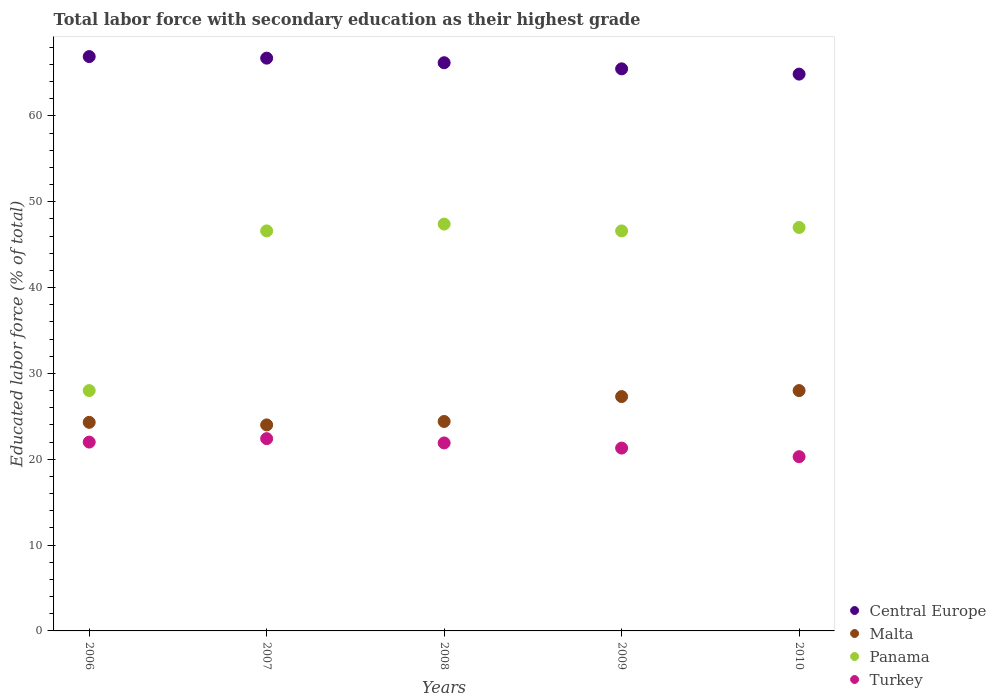How many different coloured dotlines are there?
Provide a succinct answer. 4. What is the percentage of total labor force with primary education in Central Europe in 2009?
Offer a very short reply. 65.48. Across all years, what is the maximum percentage of total labor force with primary education in Turkey?
Your response must be concise. 22.4. Across all years, what is the minimum percentage of total labor force with primary education in Turkey?
Your response must be concise. 20.3. What is the total percentage of total labor force with primary education in Malta in the graph?
Your answer should be compact. 128. What is the difference between the percentage of total labor force with primary education in Turkey in 2006 and that in 2008?
Offer a terse response. 0.1. What is the difference between the percentage of total labor force with primary education in Panama in 2008 and the percentage of total labor force with primary education in Central Europe in 2010?
Make the answer very short. -17.47. What is the average percentage of total labor force with primary education in Panama per year?
Ensure brevity in your answer.  43.12. In the year 2006, what is the difference between the percentage of total labor force with primary education in Malta and percentage of total labor force with primary education in Panama?
Keep it short and to the point. -3.7. In how many years, is the percentage of total labor force with primary education in Central Europe greater than 2 %?
Ensure brevity in your answer.  5. What is the difference between the highest and the second highest percentage of total labor force with primary education in Central Europe?
Provide a succinct answer. 0.18. What is the difference between the highest and the lowest percentage of total labor force with primary education in Turkey?
Provide a short and direct response. 2.1. In how many years, is the percentage of total labor force with primary education in Malta greater than the average percentage of total labor force with primary education in Malta taken over all years?
Your response must be concise. 2. Is the sum of the percentage of total labor force with primary education in Turkey in 2007 and 2009 greater than the maximum percentage of total labor force with primary education in Malta across all years?
Provide a succinct answer. Yes. Does the percentage of total labor force with primary education in Panama monotonically increase over the years?
Ensure brevity in your answer.  No. How many years are there in the graph?
Keep it short and to the point. 5. What is the difference between two consecutive major ticks on the Y-axis?
Offer a terse response. 10. Does the graph contain grids?
Give a very brief answer. No. Where does the legend appear in the graph?
Provide a short and direct response. Bottom right. How many legend labels are there?
Your answer should be compact. 4. How are the legend labels stacked?
Keep it short and to the point. Vertical. What is the title of the graph?
Offer a terse response. Total labor force with secondary education as their highest grade. Does "Nepal" appear as one of the legend labels in the graph?
Offer a terse response. No. What is the label or title of the Y-axis?
Keep it short and to the point. Educated labor force (% of total). What is the Educated labor force (% of total) in Central Europe in 2006?
Ensure brevity in your answer.  66.91. What is the Educated labor force (% of total) in Malta in 2006?
Keep it short and to the point. 24.3. What is the Educated labor force (% of total) in Turkey in 2006?
Keep it short and to the point. 22. What is the Educated labor force (% of total) in Central Europe in 2007?
Ensure brevity in your answer.  66.73. What is the Educated labor force (% of total) of Panama in 2007?
Your response must be concise. 46.6. What is the Educated labor force (% of total) in Turkey in 2007?
Keep it short and to the point. 22.4. What is the Educated labor force (% of total) of Central Europe in 2008?
Your answer should be compact. 66.19. What is the Educated labor force (% of total) of Malta in 2008?
Keep it short and to the point. 24.4. What is the Educated labor force (% of total) of Panama in 2008?
Offer a very short reply. 47.4. What is the Educated labor force (% of total) of Turkey in 2008?
Provide a succinct answer. 21.9. What is the Educated labor force (% of total) in Central Europe in 2009?
Offer a very short reply. 65.48. What is the Educated labor force (% of total) of Malta in 2009?
Your answer should be compact. 27.3. What is the Educated labor force (% of total) in Panama in 2009?
Provide a succinct answer. 46.6. What is the Educated labor force (% of total) of Turkey in 2009?
Provide a succinct answer. 21.3. What is the Educated labor force (% of total) of Central Europe in 2010?
Provide a succinct answer. 64.87. What is the Educated labor force (% of total) in Turkey in 2010?
Your answer should be compact. 20.3. Across all years, what is the maximum Educated labor force (% of total) of Central Europe?
Provide a short and direct response. 66.91. Across all years, what is the maximum Educated labor force (% of total) of Panama?
Offer a very short reply. 47.4. Across all years, what is the maximum Educated labor force (% of total) in Turkey?
Provide a succinct answer. 22.4. Across all years, what is the minimum Educated labor force (% of total) in Central Europe?
Make the answer very short. 64.87. Across all years, what is the minimum Educated labor force (% of total) of Malta?
Keep it short and to the point. 24. Across all years, what is the minimum Educated labor force (% of total) of Panama?
Provide a short and direct response. 28. Across all years, what is the minimum Educated labor force (% of total) in Turkey?
Your answer should be very brief. 20.3. What is the total Educated labor force (% of total) in Central Europe in the graph?
Give a very brief answer. 330.18. What is the total Educated labor force (% of total) of Malta in the graph?
Your response must be concise. 128. What is the total Educated labor force (% of total) of Panama in the graph?
Make the answer very short. 215.6. What is the total Educated labor force (% of total) of Turkey in the graph?
Give a very brief answer. 107.9. What is the difference between the Educated labor force (% of total) of Central Europe in 2006 and that in 2007?
Make the answer very short. 0.18. What is the difference between the Educated labor force (% of total) in Panama in 2006 and that in 2007?
Ensure brevity in your answer.  -18.6. What is the difference between the Educated labor force (% of total) in Central Europe in 2006 and that in 2008?
Offer a very short reply. 0.72. What is the difference between the Educated labor force (% of total) of Panama in 2006 and that in 2008?
Ensure brevity in your answer.  -19.4. What is the difference between the Educated labor force (% of total) of Central Europe in 2006 and that in 2009?
Your answer should be compact. 1.43. What is the difference between the Educated labor force (% of total) in Malta in 2006 and that in 2009?
Your response must be concise. -3. What is the difference between the Educated labor force (% of total) in Panama in 2006 and that in 2009?
Provide a short and direct response. -18.6. What is the difference between the Educated labor force (% of total) of Central Europe in 2006 and that in 2010?
Make the answer very short. 2.04. What is the difference between the Educated labor force (% of total) of Central Europe in 2007 and that in 2008?
Offer a terse response. 0.53. What is the difference between the Educated labor force (% of total) of Panama in 2007 and that in 2008?
Ensure brevity in your answer.  -0.8. What is the difference between the Educated labor force (% of total) in Central Europe in 2007 and that in 2009?
Give a very brief answer. 1.25. What is the difference between the Educated labor force (% of total) of Malta in 2007 and that in 2009?
Keep it short and to the point. -3.3. What is the difference between the Educated labor force (% of total) of Central Europe in 2007 and that in 2010?
Keep it short and to the point. 1.86. What is the difference between the Educated labor force (% of total) of Malta in 2007 and that in 2010?
Make the answer very short. -4. What is the difference between the Educated labor force (% of total) of Panama in 2007 and that in 2010?
Your response must be concise. -0.4. What is the difference between the Educated labor force (% of total) of Turkey in 2007 and that in 2010?
Ensure brevity in your answer.  2.1. What is the difference between the Educated labor force (% of total) of Central Europe in 2008 and that in 2009?
Offer a very short reply. 0.71. What is the difference between the Educated labor force (% of total) in Malta in 2008 and that in 2009?
Your response must be concise. -2.9. What is the difference between the Educated labor force (% of total) of Panama in 2008 and that in 2009?
Your answer should be compact. 0.8. What is the difference between the Educated labor force (% of total) in Central Europe in 2008 and that in 2010?
Your response must be concise. 1.33. What is the difference between the Educated labor force (% of total) of Malta in 2008 and that in 2010?
Make the answer very short. -3.6. What is the difference between the Educated labor force (% of total) of Panama in 2008 and that in 2010?
Give a very brief answer. 0.4. What is the difference between the Educated labor force (% of total) in Central Europe in 2009 and that in 2010?
Ensure brevity in your answer.  0.61. What is the difference between the Educated labor force (% of total) in Malta in 2009 and that in 2010?
Offer a terse response. -0.7. What is the difference between the Educated labor force (% of total) of Central Europe in 2006 and the Educated labor force (% of total) of Malta in 2007?
Offer a very short reply. 42.91. What is the difference between the Educated labor force (% of total) of Central Europe in 2006 and the Educated labor force (% of total) of Panama in 2007?
Your response must be concise. 20.31. What is the difference between the Educated labor force (% of total) in Central Europe in 2006 and the Educated labor force (% of total) in Turkey in 2007?
Provide a short and direct response. 44.51. What is the difference between the Educated labor force (% of total) of Malta in 2006 and the Educated labor force (% of total) of Panama in 2007?
Your answer should be compact. -22.3. What is the difference between the Educated labor force (% of total) in Malta in 2006 and the Educated labor force (% of total) in Turkey in 2007?
Your response must be concise. 1.9. What is the difference between the Educated labor force (% of total) in Central Europe in 2006 and the Educated labor force (% of total) in Malta in 2008?
Provide a short and direct response. 42.51. What is the difference between the Educated labor force (% of total) of Central Europe in 2006 and the Educated labor force (% of total) of Panama in 2008?
Offer a terse response. 19.51. What is the difference between the Educated labor force (% of total) of Central Europe in 2006 and the Educated labor force (% of total) of Turkey in 2008?
Provide a short and direct response. 45.01. What is the difference between the Educated labor force (% of total) in Malta in 2006 and the Educated labor force (% of total) in Panama in 2008?
Provide a succinct answer. -23.1. What is the difference between the Educated labor force (% of total) of Malta in 2006 and the Educated labor force (% of total) of Turkey in 2008?
Ensure brevity in your answer.  2.4. What is the difference between the Educated labor force (% of total) of Central Europe in 2006 and the Educated labor force (% of total) of Malta in 2009?
Offer a very short reply. 39.61. What is the difference between the Educated labor force (% of total) of Central Europe in 2006 and the Educated labor force (% of total) of Panama in 2009?
Give a very brief answer. 20.31. What is the difference between the Educated labor force (% of total) in Central Europe in 2006 and the Educated labor force (% of total) in Turkey in 2009?
Your response must be concise. 45.61. What is the difference between the Educated labor force (% of total) in Malta in 2006 and the Educated labor force (% of total) in Panama in 2009?
Keep it short and to the point. -22.3. What is the difference between the Educated labor force (% of total) in Panama in 2006 and the Educated labor force (% of total) in Turkey in 2009?
Give a very brief answer. 6.7. What is the difference between the Educated labor force (% of total) of Central Europe in 2006 and the Educated labor force (% of total) of Malta in 2010?
Ensure brevity in your answer.  38.91. What is the difference between the Educated labor force (% of total) in Central Europe in 2006 and the Educated labor force (% of total) in Panama in 2010?
Provide a succinct answer. 19.91. What is the difference between the Educated labor force (% of total) in Central Europe in 2006 and the Educated labor force (% of total) in Turkey in 2010?
Your answer should be very brief. 46.61. What is the difference between the Educated labor force (% of total) of Malta in 2006 and the Educated labor force (% of total) of Panama in 2010?
Provide a short and direct response. -22.7. What is the difference between the Educated labor force (% of total) of Panama in 2006 and the Educated labor force (% of total) of Turkey in 2010?
Offer a very short reply. 7.7. What is the difference between the Educated labor force (% of total) in Central Europe in 2007 and the Educated labor force (% of total) in Malta in 2008?
Keep it short and to the point. 42.33. What is the difference between the Educated labor force (% of total) in Central Europe in 2007 and the Educated labor force (% of total) in Panama in 2008?
Make the answer very short. 19.33. What is the difference between the Educated labor force (% of total) in Central Europe in 2007 and the Educated labor force (% of total) in Turkey in 2008?
Offer a very short reply. 44.83. What is the difference between the Educated labor force (% of total) of Malta in 2007 and the Educated labor force (% of total) of Panama in 2008?
Make the answer very short. -23.4. What is the difference between the Educated labor force (% of total) in Malta in 2007 and the Educated labor force (% of total) in Turkey in 2008?
Offer a terse response. 2.1. What is the difference between the Educated labor force (% of total) of Panama in 2007 and the Educated labor force (% of total) of Turkey in 2008?
Keep it short and to the point. 24.7. What is the difference between the Educated labor force (% of total) of Central Europe in 2007 and the Educated labor force (% of total) of Malta in 2009?
Offer a terse response. 39.43. What is the difference between the Educated labor force (% of total) of Central Europe in 2007 and the Educated labor force (% of total) of Panama in 2009?
Your answer should be compact. 20.13. What is the difference between the Educated labor force (% of total) in Central Europe in 2007 and the Educated labor force (% of total) in Turkey in 2009?
Your answer should be compact. 45.43. What is the difference between the Educated labor force (% of total) of Malta in 2007 and the Educated labor force (% of total) of Panama in 2009?
Offer a very short reply. -22.6. What is the difference between the Educated labor force (% of total) of Malta in 2007 and the Educated labor force (% of total) of Turkey in 2009?
Keep it short and to the point. 2.7. What is the difference between the Educated labor force (% of total) in Panama in 2007 and the Educated labor force (% of total) in Turkey in 2009?
Provide a succinct answer. 25.3. What is the difference between the Educated labor force (% of total) of Central Europe in 2007 and the Educated labor force (% of total) of Malta in 2010?
Offer a terse response. 38.73. What is the difference between the Educated labor force (% of total) of Central Europe in 2007 and the Educated labor force (% of total) of Panama in 2010?
Keep it short and to the point. 19.73. What is the difference between the Educated labor force (% of total) of Central Europe in 2007 and the Educated labor force (% of total) of Turkey in 2010?
Your answer should be very brief. 46.43. What is the difference between the Educated labor force (% of total) in Panama in 2007 and the Educated labor force (% of total) in Turkey in 2010?
Offer a terse response. 26.3. What is the difference between the Educated labor force (% of total) of Central Europe in 2008 and the Educated labor force (% of total) of Malta in 2009?
Give a very brief answer. 38.89. What is the difference between the Educated labor force (% of total) in Central Europe in 2008 and the Educated labor force (% of total) in Panama in 2009?
Give a very brief answer. 19.59. What is the difference between the Educated labor force (% of total) in Central Europe in 2008 and the Educated labor force (% of total) in Turkey in 2009?
Offer a very short reply. 44.89. What is the difference between the Educated labor force (% of total) of Malta in 2008 and the Educated labor force (% of total) of Panama in 2009?
Offer a terse response. -22.2. What is the difference between the Educated labor force (% of total) in Panama in 2008 and the Educated labor force (% of total) in Turkey in 2009?
Make the answer very short. 26.1. What is the difference between the Educated labor force (% of total) of Central Europe in 2008 and the Educated labor force (% of total) of Malta in 2010?
Your response must be concise. 38.19. What is the difference between the Educated labor force (% of total) in Central Europe in 2008 and the Educated labor force (% of total) in Panama in 2010?
Give a very brief answer. 19.19. What is the difference between the Educated labor force (% of total) in Central Europe in 2008 and the Educated labor force (% of total) in Turkey in 2010?
Offer a terse response. 45.89. What is the difference between the Educated labor force (% of total) of Malta in 2008 and the Educated labor force (% of total) of Panama in 2010?
Your response must be concise. -22.6. What is the difference between the Educated labor force (% of total) of Malta in 2008 and the Educated labor force (% of total) of Turkey in 2010?
Give a very brief answer. 4.1. What is the difference between the Educated labor force (% of total) of Panama in 2008 and the Educated labor force (% of total) of Turkey in 2010?
Your answer should be very brief. 27.1. What is the difference between the Educated labor force (% of total) of Central Europe in 2009 and the Educated labor force (% of total) of Malta in 2010?
Offer a very short reply. 37.48. What is the difference between the Educated labor force (% of total) in Central Europe in 2009 and the Educated labor force (% of total) in Panama in 2010?
Your answer should be very brief. 18.48. What is the difference between the Educated labor force (% of total) of Central Europe in 2009 and the Educated labor force (% of total) of Turkey in 2010?
Provide a short and direct response. 45.18. What is the difference between the Educated labor force (% of total) in Malta in 2009 and the Educated labor force (% of total) in Panama in 2010?
Offer a terse response. -19.7. What is the difference between the Educated labor force (% of total) of Malta in 2009 and the Educated labor force (% of total) of Turkey in 2010?
Your answer should be very brief. 7. What is the difference between the Educated labor force (% of total) in Panama in 2009 and the Educated labor force (% of total) in Turkey in 2010?
Offer a terse response. 26.3. What is the average Educated labor force (% of total) of Central Europe per year?
Your answer should be compact. 66.04. What is the average Educated labor force (% of total) of Malta per year?
Give a very brief answer. 25.6. What is the average Educated labor force (% of total) of Panama per year?
Keep it short and to the point. 43.12. What is the average Educated labor force (% of total) of Turkey per year?
Your response must be concise. 21.58. In the year 2006, what is the difference between the Educated labor force (% of total) in Central Europe and Educated labor force (% of total) in Malta?
Your answer should be very brief. 42.61. In the year 2006, what is the difference between the Educated labor force (% of total) in Central Europe and Educated labor force (% of total) in Panama?
Offer a very short reply. 38.91. In the year 2006, what is the difference between the Educated labor force (% of total) in Central Europe and Educated labor force (% of total) in Turkey?
Ensure brevity in your answer.  44.91. In the year 2006, what is the difference between the Educated labor force (% of total) of Malta and Educated labor force (% of total) of Turkey?
Offer a very short reply. 2.3. In the year 2007, what is the difference between the Educated labor force (% of total) in Central Europe and Educated labor force (% of total) in Malta?
Offer a very short reply. 42.73. In the year 2007, what is the difference between the Educated labor force (% of total) of Central Europe and Educated labor force (% of total) of Panama?
Provide a succinct answer. 20.13. In the year 2007, what is the difference between the Educated labor force (% of total) in Central Europe and Educated labor force (% of total) in Turkey?
Offer a very short reply. 44.33. In the year 2007, what is the difference between the Educated labor force (% of total) in Malta and Educated labor force (% of total) in Panama?
Your answer should be very brief. -22.6. In the year 2007, what is the difference between the Educated labor force (% of total) in Malta and Educated labor force (% of total) in Turkey?
Your answer should be compact. 1.6. In the year 2007, what is the difference between the Educated labor force (% of total) in Panama and Educated labor force (% of total) in Turkey?
Offer a very short reply. 24.2. In the year 2008, what is the difference between the Educated labor force (% of total) of Central Europe and Educated labor force (% of total) of Malta?
Provide a short and direct response. 41.79. In the year 2008, what is the difference between the Educated labor force (% of total) in Central Europe and Educated labor force (% of total) in Panama?
Make the answer very short. 18.79. In the year 2008, what is the difference between the Educated labor force (% of total) in Central Europe and Educated labor force (% of total) in Turkey?
Offer a very short reply. 44.29. In the year 2008, what is the difference between the Educated labor force (% of total) in Malta and Educated labor force (% of total) in Panama?
Your response must be concise. -23. In the year 2008, what is the difference between the Educated labor force (% of total) in Malta and Educated labor force (% of total) in Turkey?
Give a very brief answer. 2.5. In the year 2009, what is the difference between the Educated labor force (% of total) of Central Europe and Educated labor force (% of total) of Malta?
Provide a succinct answer. 38.18. In the year 2009, what is the difference between the Educated labor force (% of total) of Central Europe and Educated labor force (% of total) of Panama?
Keep it short and to the point. 18.88. In the year 2009, what is the difference between the Educated labor force (% of total) of Central Europe and Educated labor force (% of total) of Turkey?
Offer a terse response. 44.18. In the year 2009, what is the difference between the Educated labor force (% of total) in Malta and Educated labor force (% of total) in Panama?
Give a very brief answer. -19.3. In the year 2009, what is the difference between the Educated labor force (% of total) in Malta and Educated labor force (% of total) in Turkey?
Offer a terse response. 6. In the year 2009, what is the difference between the Educated labor force (% of total) in Panama and Educated labor force (% of total) in Turkey?
Give a very brief answer. 25.3. In the year 2010, what is the difference between the Educated labor force (% of total) of Central Europe and Educated labor force (% of total) of Malta?
Offer a very short reply. 36.87. In the year 2010, what is the difference between the Educated labor force (% of total) of Central Europe and Educated labor force (% of total) of Panama?
Offer a very short reply. 17.87. In the year 2010, what is the difference between the Educated labor force (% of total) in Central Europe and Educated labor force (% of total) in Turkey?
Keep it short and to the point. 44.57. In the year 2010, what is the difference between the Educated labor force (% of total) in Malta and Educated labor force (% of total) in Turkey?
Your answer should be very brief. 7.7. In the year 2010, what is the difference between the Educated labor force (% of total) in Panama and Educated labor force (% of total) in Turkey?
Your answer should be compact. 26.7. What is the ratio of the Educated labor force (% of total) of Malta in 2006 to that in 2007?
Your answer should be very brief. 1.01. What is the ratio of the Educated labor force (% of total) in Panama in 2006 to that in 2007?
Your answer should be very brief. 0.6. What is the ratio of the Educated labor force (% of total) of Turkey in 2006 to that in 2007?
Give a very brief answer. 0.98. What is the ratio of the Educated labor force (% of total) of Central Europe in 2006 to that in 2008?
Offer a terse response. 1.01. What is the ratio of the Educated labor force (% of total) of Panama in 2006 to that in 2008?
Your answer should be compact. 0.59. What is the ratio of the Educated labor force (% of total) in Turkey in 2006 to that in 2008?
Give a very brief answer. 1. What is the ratio of the Educated labor force (% of total) in Central Europe in 2006 to that in 2009?
Keep it short and to the point. 1.02. What is the ratio of the Educated labor force (% of total) in Malta in 2006 to that in 2009?
Give a very brief answer. 0.89. What is the ratio of the Educated labor force (% of total) in Panama in 2006 to that in 2009?
Keep it short and to the point. 0.6. What is the ratio of the Educated labor force (% of total) in Turkey in 2006 to that in 2009?
Your response must be concise. 1.03. What is the ratio of the Educated labor force (% of total) of Central Europe in 2006 to that in 2010?
Your answer should be compact. 1.03. What is the ratio of the Educated labor force (% of total) of Malta in 2006 to that in 2010?
Your response must be concise. 0.87. What is the ratio of the Educated labor force (% of total) of Panama in 2006 to that in 2010?
Your answer should be compact. 0.6. What is the ratio of the Educated labor force (% of total) in Turkey in 2006 to that in 2010?
Provide a succinct answer. 1.08. What is the ratio of the Educated labor force (% of total) in Central Europe in 2007 to that in 2008?
Make the answer very short. 1.01. What is the ratio of the Educated labor force (% of total) in Malta in 2007 to that in 2008?
Offer a very short reply. 0.98. What is the ratio of the Educated labor force (% of total) of Panama in 2007 to that in 2008?
Offer a very short reply. 0.98. What is the ratio of the Educated labor force (% of total) in Turkey in 2007 to that in 2008?
Give a very brief answer. 1.02. What is the ratio of the Educated labor force (% of total) in Malta in 2007 to that in 2009?
Provide a succinct answer. 0.88. What is the ratio of the Educated labor force (% of total) in Turkey in 2007 to that in 2009?
Provide a short and direct response. 1.05. What is the ratio of the Educated labor force (% of total) of Central Europe in 2007 to that in 2010?
Your answer should be compact. 1.03. What is the ratio of the Educated labor force (% of total) in Malta in 2007 to that in 2010?
Your answer should be compact. 0.86. What is the ratio of the Educated labor force (% of total) of Panama in 2007 to that in 2010?
Offer a very short reply. 0.99. What is the ratio of the Educated labor force (% of total) of Turkey in 2007 to that in 2010?
Your answer should be compact. 1.1. What is the ratio of the Educated labor force (% of total) in Central Europe in 2008 to that in 2009?
Your answer should be very brief. 1.01. What is the ratio of the Educated labor force (% of total) in Malta in 2008 to that in 2009?
Offer a terse response. 0.89. What is the ratio of the Educated labor force (% of total) in Panama in 2008 to that in 2009?
Your response must be concise. 1.02. What is the ratio of the Educated labor force (% of total) in Turkey in 2008 to that in 2009?
Your answer should be compact. 1.03. What is the ratio of the Educated labor force (% of total) in Central Europe in 2008 to that in 2010?
Provide a succinct answer. 1.02. What is the ratio of the Educated labor force (% of total) of Malta in 2008 to that in 2010?
Offer a very short reply. 0.87. What is the ratio of the Educated labor force (% of total) in Panama in 2008 to that in 2010?
Your response must be concise. 1.01. What is the ratio of the Educated labor force (% of total) of Turkey in 2008 to that in 2010?
Provide a succinct answer. 1.08. What is the ratio of the Educated labor force (% of total) of Central Europe in 2009 to that in 2010?
Offer a very short reply. 1.01. What is the ratio of the Educated labor force (% of total) in Turkey in 2009 to that in 2010?
Provide a succinct answer. 1.05. What is the difference between the highest and the second highest Educated labor force (% of total) in Central Europe?
Your response must be concise. 0.18. What is the difference between the highest and the second highest Educated labor force (% of total) of Malta?
Keep it short and to the point. 0.7. What is the difference between the highest and the lowest Educated labor force (% of total) in Central Europe?
Your response must be concise. 2.04. What is the difference between the highest and the lowest Educated labor force (% of total) in Panama?
Your response must be concise. 19.4. What is the difference between the highest and the lowest Educated labor force (% of total) of Turkey?
Your response must be concise. 2.1. 